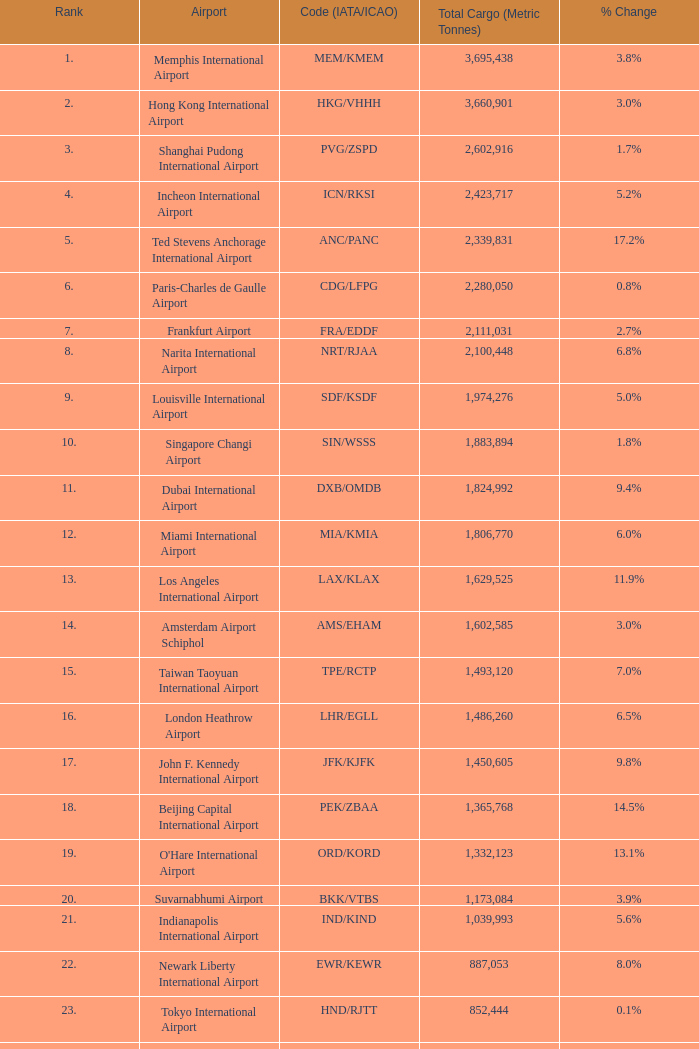What is the position of ord/kord when the total cargo surpasses 1,332,123? None. 